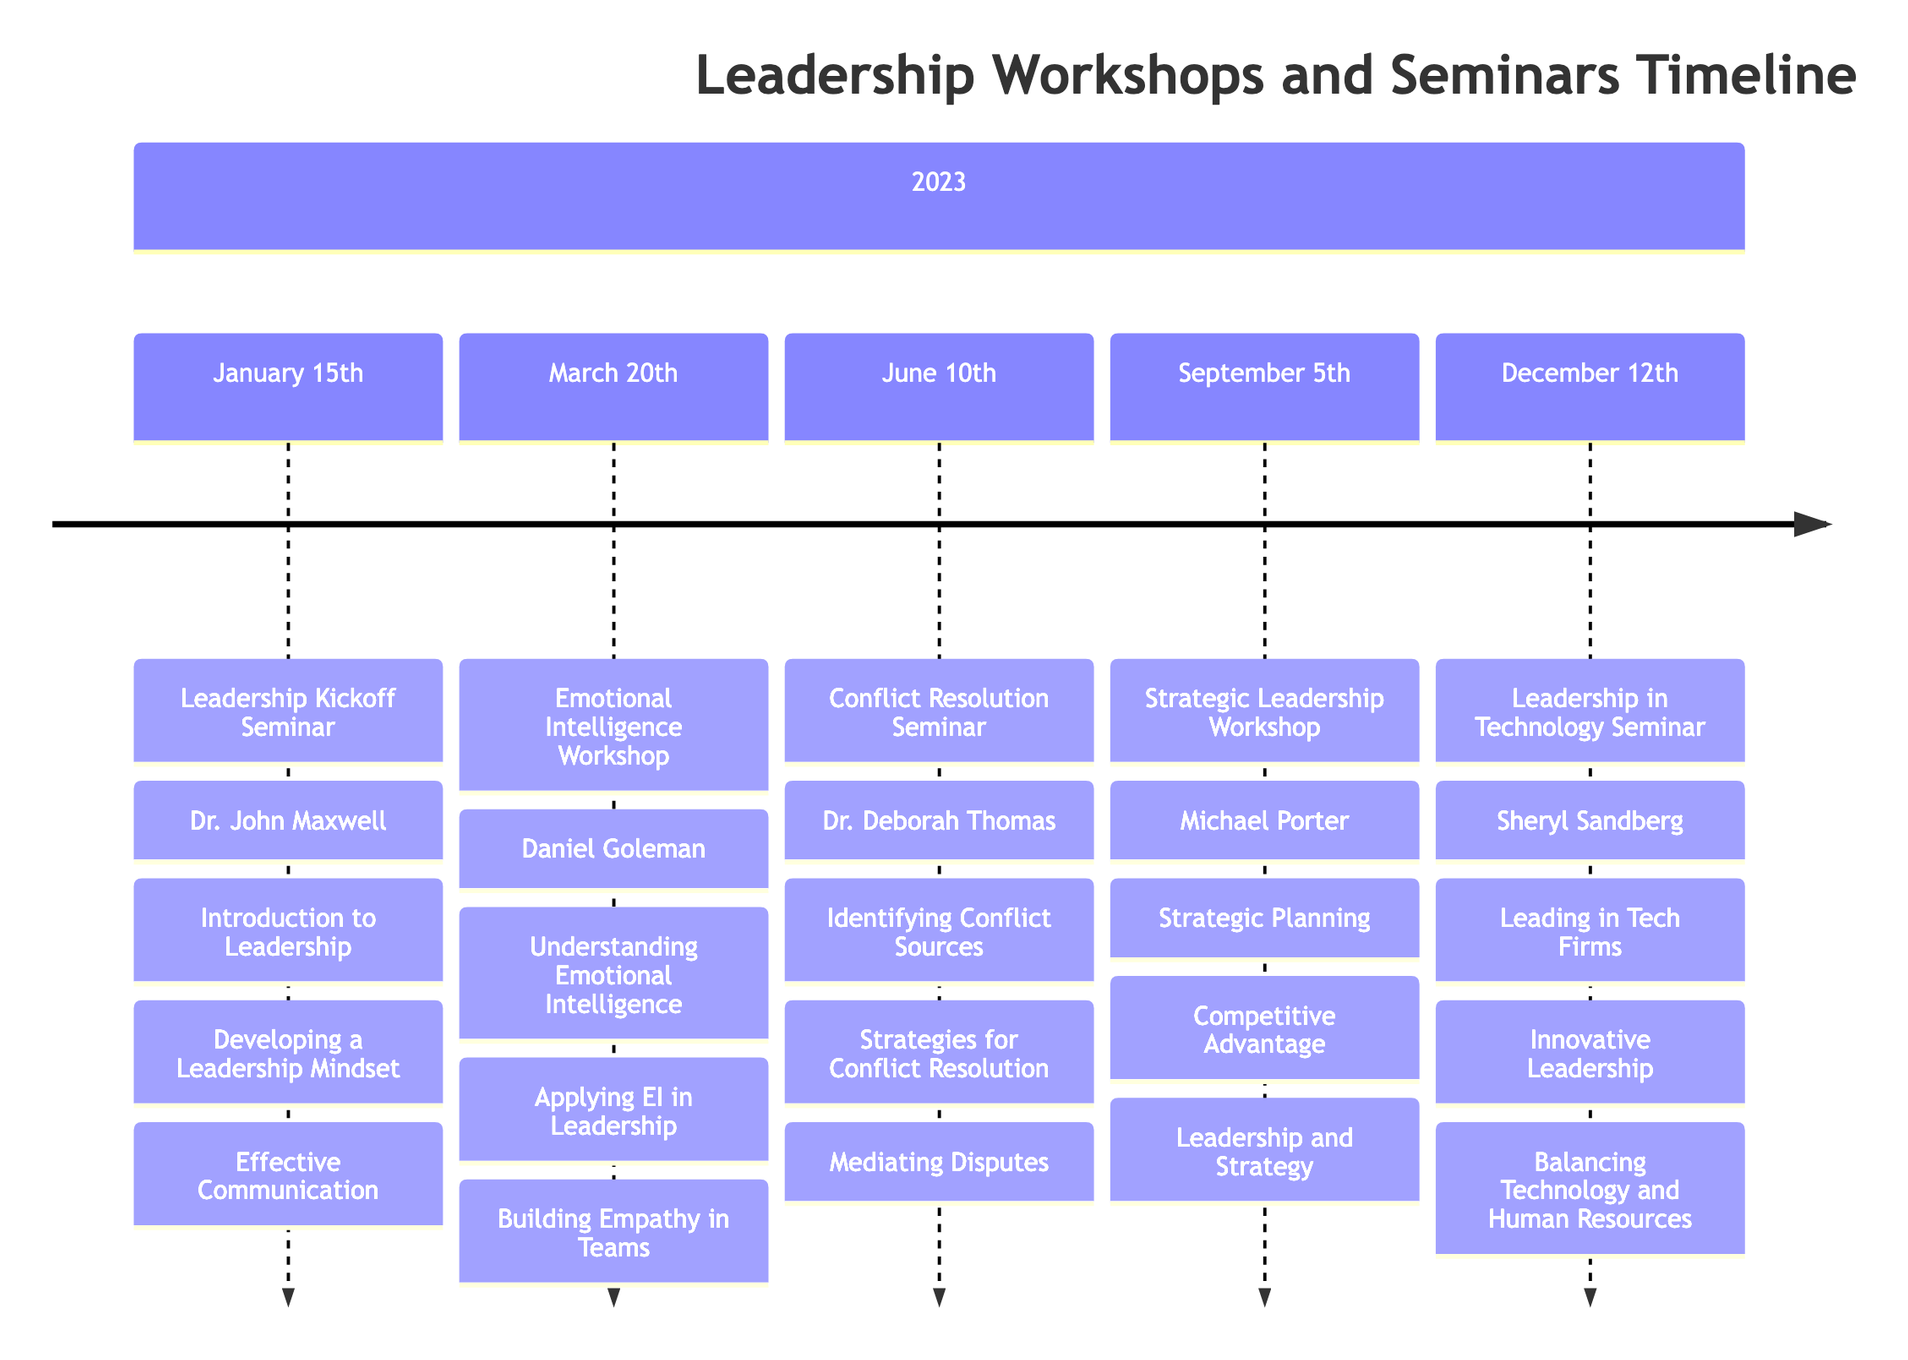What is the date of the Leadership Kickoff Seminar? The Leadership Kickoff Seminar is listed under the section for January 2023. The specific date provided is January 15th, 2023.
Answer: January 15th, 2023 Who was the guest speaker for the Emotional Intelligence Workshop? The Emotional Intelligence Workshop, occurring on March 20th, 2023, had Daniel Goleman as the featured guest speaker.
Answer: Daniel Goleman How many topics were covered in the Conflict Resolution Seminar? The Conflict Resolution Seminar, held on June 10th, 2023, included three topics as listed directly beneath the event title.
Answer: Three What topic was discussed at the Strategic Leadership Workshop? The Strategic Leadership Workshop took place on September 5th, 2023, and covered multiple topics, including Strategic Planning, Competitive Advantage, and Leadership and Strategy.
Answer: Strategic Planning Which guest speaker presented at the Leadership in Technology Seminar? As per the provided timeline, the Leadership in Technology Seminar on December 12th, 2023, featured Sheryl Sandberg as the guest speaker.
Answer: Sheryl Sandberg What positive feedback did Emily Davis give about the session on December 12th? The timeline shows that Emily Davis found the session highly insightful and expressed that Sheryl Sandberg is an amazing speaker.
Answer: Insightful session on tech leadership Which seminar was about conflict resolution? The title of the seminar focused on conflict resolution is identified in the timeline as the Conflict Resolution Seminar, and it occurred on June 10th, 2023.
Answer: Conflict Resolution Seminar Adding up the number of workshops and seminars conducted in 2023, what is the total? The timeline indicates five distinct events throughout 2023, starting from January and ending in December.
Answer: Five 